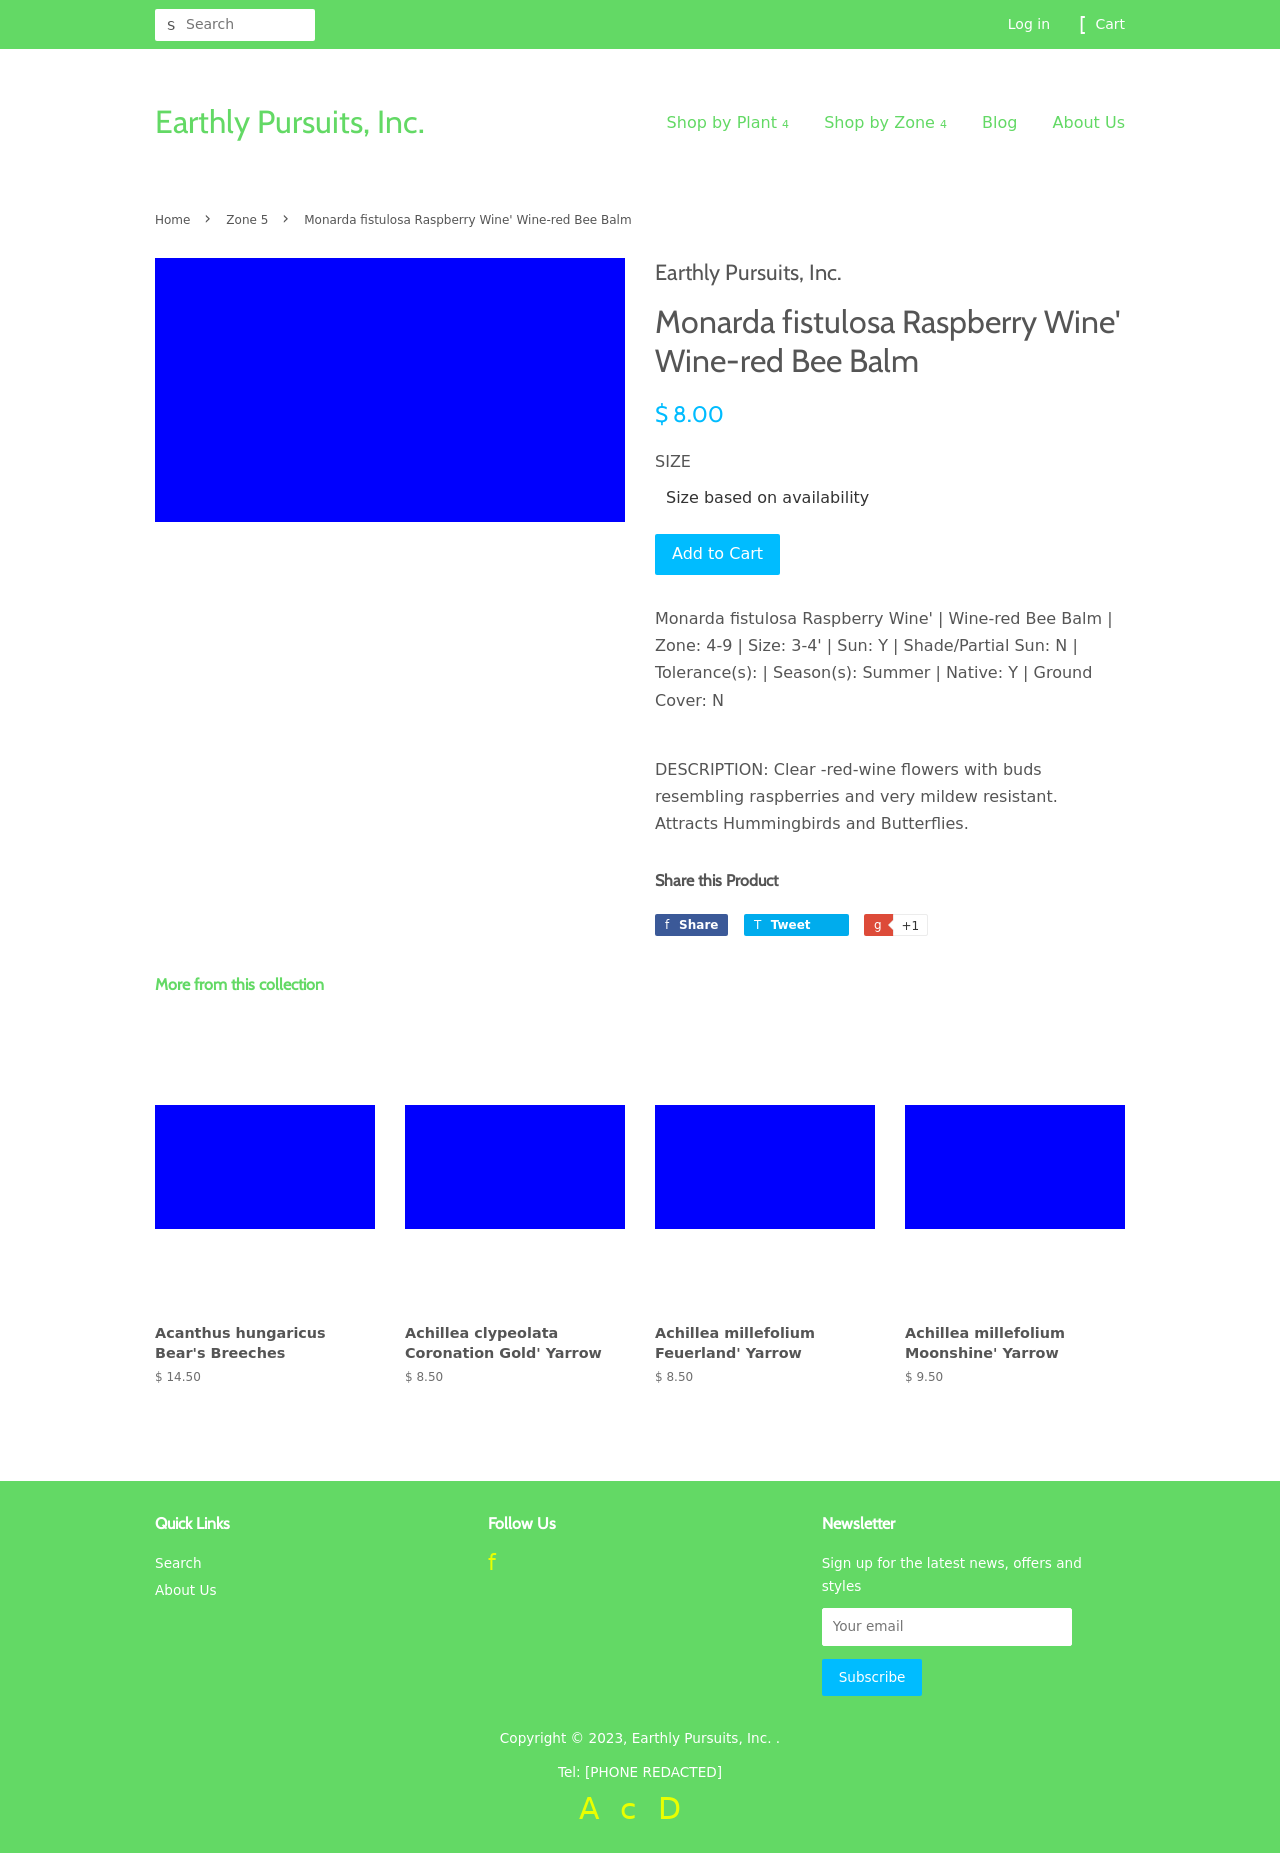What's the procedure for constructing this website from scratch with HTML? To construct a website like the one shown in the image from scratch using HTML, you need to follow several steps: Firstly, set up a basic HTML structure using the <!DOCTYPE html>, <html>, <head>, and <body> tags. Inside the <head>, include links to CSS for styling and possibly JavaScript for dynamic elements. In the <body>, structure your content using semantic HTML elements like <header>, <nav>, <main>, <section>, and <footer>. Use <div> or <section> elements to create layout divisions, and apply appropriate IDs and classes for CSS styling. Finally, paste the content into the appropriate sections, add image references, links, product descriptions, and ensure the forms are functional with appropriate actions and methods. Frequently test your website in different browsers and adjust the HTML and CSS to ensure compatibility and responsiveness. 